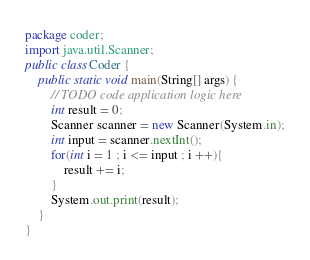Convert code to text. <code><loc_0><loc_0><loc_500><loc_500><_Java_>package coder;
import java.util.Scanner;
public class Coder {
    public static void main(String[] args) {
        // TODO code application logic here
        int result = 0;
        Scanner scanner = new Scanner(System.in);
        int input = scanner.nextInt();
        for(int i = 1 ; i <= input ; i ++){
            result += i;
        }
        System.out.print(result);
    }
}
</code> 